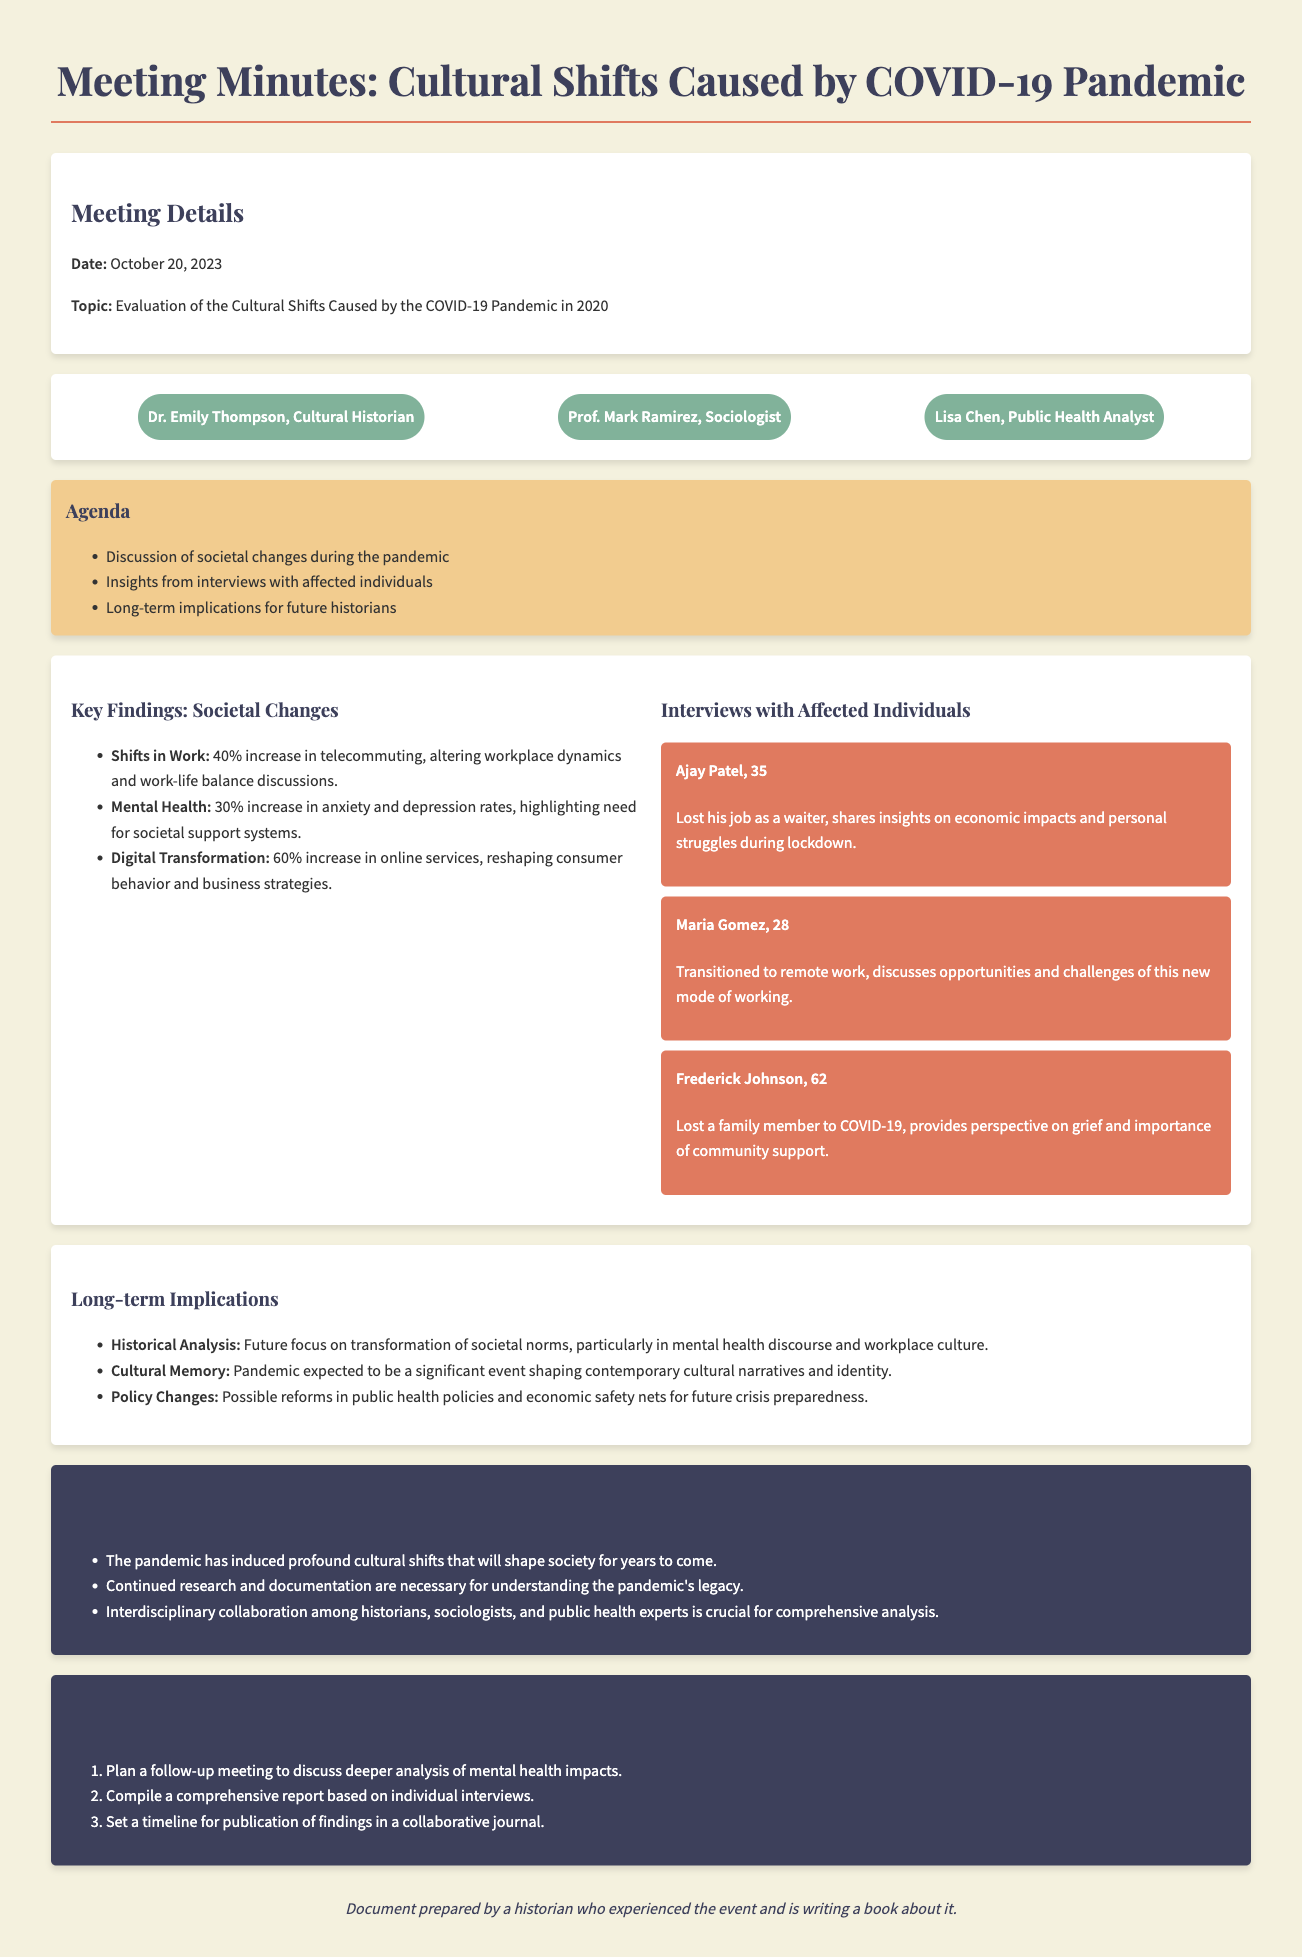what was the date of the meeting? The date of the meeting is stated at the beginning of the document under Meeting Details.
Answer: October 20, 2023 who is the cultural historian mentioned in the document? The cultural historian is named in the participants section of the document.
Answer: Dr. Emily Thompson what percentage increase in telecommuting was reported? The increase in telecommuting is listed under the Key Findings section.
Answer: 40% who expressed a perspective on grief in the interviews? This individual is mentioned in the Interviews section, providing a highly personal insight.
Answer: Frederick Johnson what is one expected long-term implication noted in the document? The long-term implications are listed in a specific section, summarizing anticipated outcomes of the pandemic.
Answer: Cultural Memory what type of collaboration is deemed crucial for analysis? The necessity of collaboration is highlighted in the Conclusions section of the document.
Answer: Interdisciplinary collaboration how many key findings are listed in the societal changes section? The Key Findings section under societal changes specifies the number of findings.
Answer: Three what is one next step outlined in the document? The next steps are detailed in a specific section outlining future actions after the meeting.
Answer: Plan a follow-up meeting 